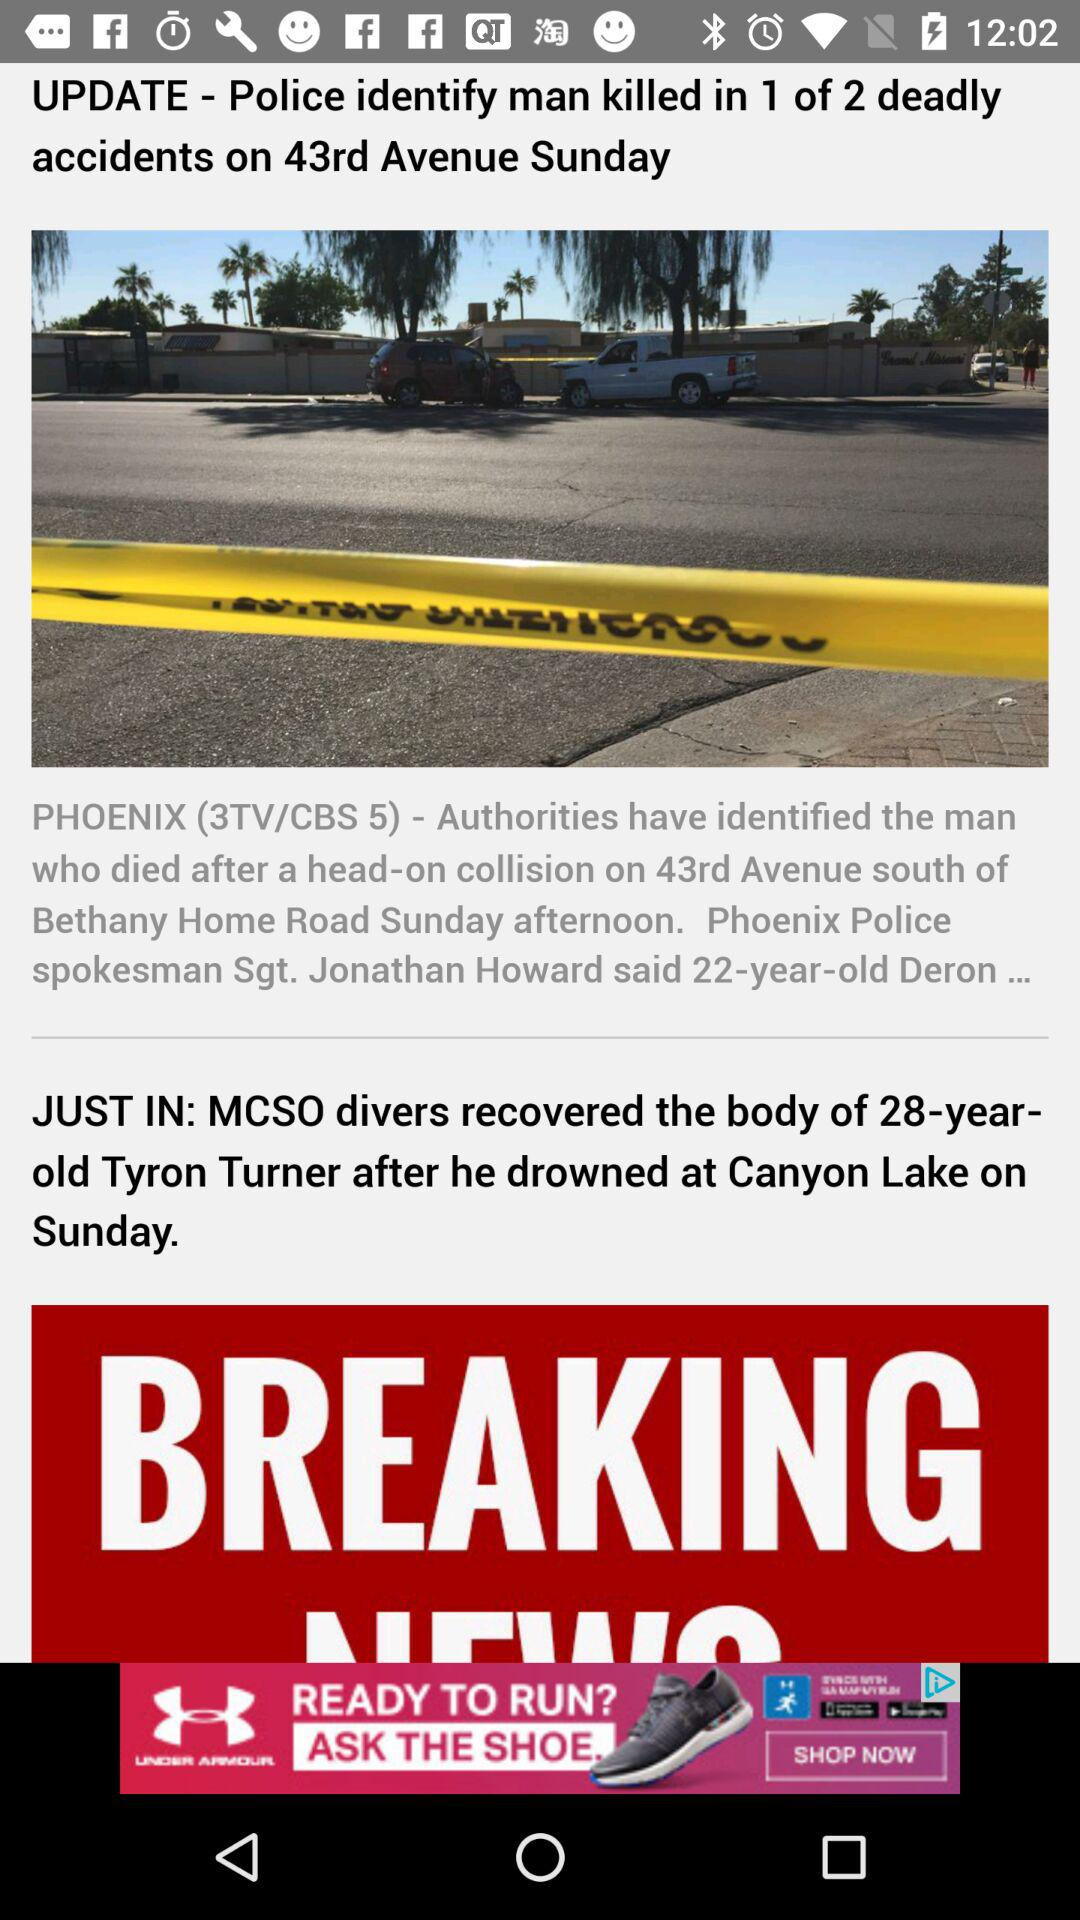At which lake did Tyron Turner drown? Tyron Turner drowned at Canyon Lake. 